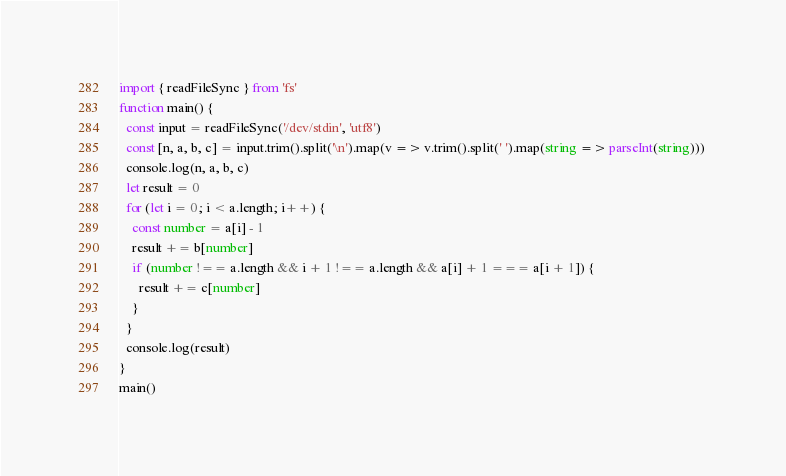Convert code to text. <code><loc_0><loc_0><loc_500><loc_500><_TypeScript_>import { readFileSync } from 'fs'
function main() {
  const input = readFileSync('/dev/stdin', 'utf8')
  const [n, a, b, c] = input.trim().split('\n').map(v => v.trim().split(' ').map(string => parseInt(string))) 
  console.log(n, a, b, c)
  let result = 0  
  for (let i = 0; i < a.length; i++) {
    const number = a[i] - 1
    result += b[number]
    if (number !== a.length && i + 1 !== a.length && a[i] + 1 === a[i + 1]) {
      result += c[number]
    }
  }
  console.log(result)
}
main()</code> 